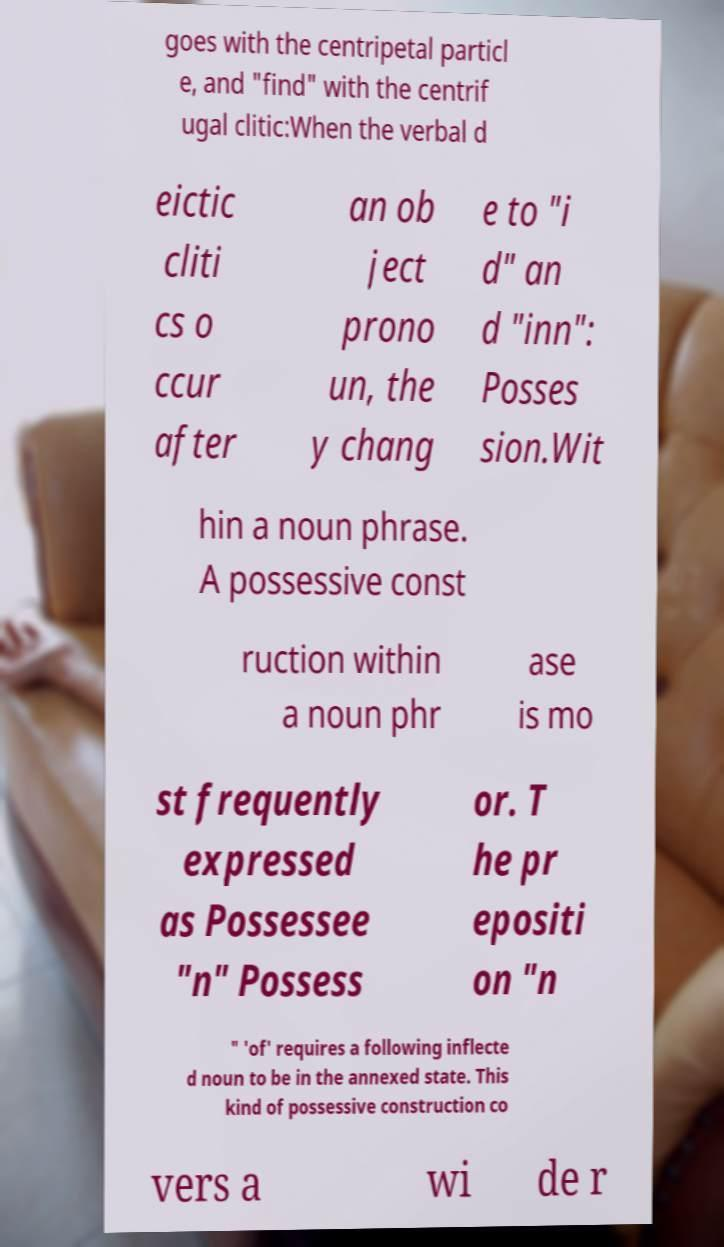Can you accurately transcribe the text from the provided image for me? goes with the centripetal particl e, and "find" with the centrif ugal clitic:When the verbal d eictic cliti cs o ccur after an ob ject prono un, the y chang e to "i d" an d "inn": Posses sion.Wit hin a noun phrase. A possessive const ruction within a noun phr ase is mo st frequently expressed as Possessee "n" Possess or. T he pr epositi on "n " 'of' requires a following inflecte d noun to be in the annexed state. This kind of possessive construction co vers a wi de r 